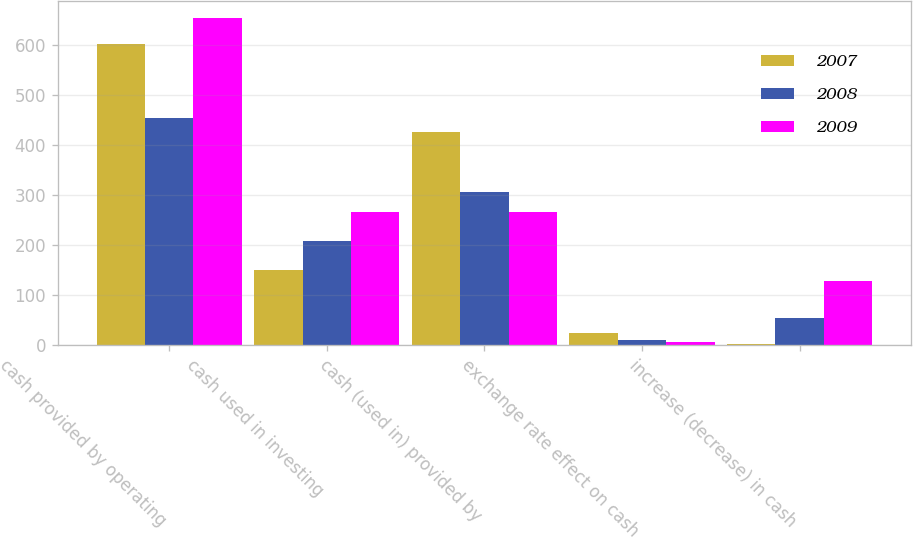Convert chart. <chart><loc_0><loc_0><loc_500><loc_500><stacked_bar_chart><ecel><fcel>cash provided by operating<fcel>cash used in investing<fcel>cash (used in) provided by<fcel>exchange rate effect on cash<fcel>increase (decrease) in cash<nl><fcel>2007<fcel>602.8<fcel>149.4<fcel>427<fcel>23.5<fcel>2.9<nl><fcel>2008<fcel>454.9<fcel>207.5<fcel>306<fcel>10.6<fcel>53.8<nl><fcel>2009<fcel>655.3<fcel>265.6<fcel>266.8<fcel>5.3<fcel>128.2<nl></chart> 